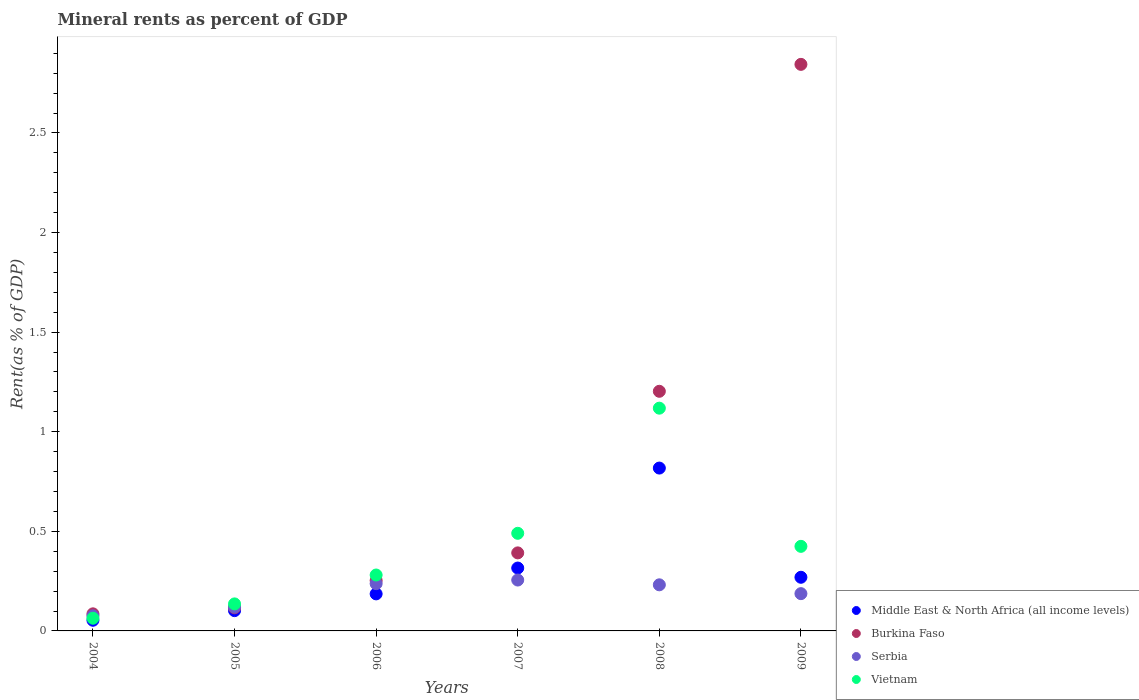Is the number of dotlines equal to the number of legend labels?
Make the answer very short. Yes. What is the mineral rent in Burkina Faso in 2008?
Make the answer very short. 1.2. Across all years, what is the maximum mineral rent in Vietnam?
Your response must be concise. 1.12. Across all years, what is the minimum mineral rent in Burkina Faso?
Your response must be concise. 0.09. In which year was the mineral rent in Middle East & North Africa (all income levels) maximum?
Your response must be concise. 2008. In which year was the mineral rent in Vietnam minimum?
Give a very brief answer. 2004. What is the total mineral rent in Middle East & North Africa (all income levels) in the graph?
Give a very brief answer. 1.74. What is the difference between the mineral rent in Middle East & North Africa (all income levels) in 2007 and that in 2008?
Make the answer very short. -0.5. What is the difference between the mineral rent in Burkina Faso in 2006 and the mineral rent in Vietnam in 2009?
Your answer should be compact. -0.17. What is the average mineral rent in Middle East & North Africa (all income levels) per year?
Your answer should be very brief. 0.29. In the year 2007, what is the difference between the mineral rent in Middle East & North Africa (all income levels) and mineral rent in Vietnam?
Keep it short and to the point. -0.17. In how many years, is the mineral rent in Burkina Faso greater than 0.30000000000000004 %?
Give a very brief answer. 3. What is the ratio of the mineral rent in Middle East & North Africa (all income levels) in 2004 to that in 2006?
Your response must be concise. 0.29. What is the difference between the highest and the second highest mineral rent in Vietnam?
Keep it short and to the point. 0.63. What is the difference between the highest and the lowest mineral rent in Middle East & North Africa (all income levels)?
Provide a short and direct response. 0.76. In how many years, is the mineral rent in Middle East & North Africa (all income levels) greater than the average mineral rent in Middle East & North Africa (all income levels) taken over all years?
Your response must be concise. 2. Is the sum of the mineral rent in Middle East & North Africa (all income levels) in 2004 and 2005 greater than the maximum mineral rent in Vietnam across all years?
Offer a terse response. No. How many dotlines are there?
Your answer should be compact. 4. Are the values on the major ticks of Y-axis written in scientific E-notation?
Your answer should be compact. No. Where does the legend appear in the graph?
Your answer should be compact. Bottom right. How are the legend labels stacked?
Give a very brief answer. Vertical. What is the title of the graph?
Offer a very short reply. Mineral rents as percent of GDP. What is the label or title of the Y-axis?
Keep it short and to the point. Rent(as % of GDP). What is the Rent(as % of GDP) in Middle East & North Africa (all income levels) in 2004?
Offer a very short reply. 0.05. What is the Rent(as % of GDP) in Burkina Faso in 2004?
Provide a succinct answer. 0.09. What is the Rent(as % of GDP) of Serbia in 2004?
Ensure brevity in your answer.  0.08. What is the Rent(as % of GDP) of Vietnam in 2004?
Give a very brief answer. 0.06. What is the Rent(as % of GDP) of Middle East & North Africa (all income levels) in 2005?
Give a very brief answer. 0.1. What is the Rent(as % of GDP) of Burkina Faso in 2005?
Give a very brief answer. 0.12. What is the Rent(as % of GDP) in Serbia in 2005?
Give a very brief answer. 0.12. What is the Rent(as % of GDP) in Vietnam in 2005?
Keep it short and to the point. 0.14. What is the Rent(as % of GDP) of Middle East & North Africa (all income levels) in 2006?
Offer a terse response. 0.19. What is the Rent(as % of GDP) in Burkina Faso in 2006?
Make the answer very short. 0.25. What is the Rent(as % of GDP) in Serbia in 2006?
Offer a terse response. 0.24. What is the Rent(as % of GDP) in Vietnam in 2006?
Offer a terse response. 0.28. What is the Rent(as % of GDP) of Middle East & North Africa (all income levels) in 2007?
Make the answer very short. 0.32. What is the Rent(as % of GDP) in Burkina Faso in 2007?
Make the answer very short. 0.39. What is the Rent(as % of GDP) of Serbia in 2007?
Keep it short and to the point. 0.26. What is the Rent(as % of GDP) of Vietnam in 2007?
Your answer should be very brief. 0.49. What is the Rent(as % of GDP) in Middle East & North Africa (all income levels) in 2008?
Offer a terse response. 0.82. What is the Rent(as % of GDP) in Burkina Faso in 2008?
Give a very brief answer. 1.2. What is the Rent(as % of GDP) in Serbia in 2008?
Offer a very short reply. 0.23. What is the Rent(as % of GDP) of Vietnam in 2008?
Your answer should be very brief. 1.12. What is the Rent(as % of GDP) of Middle East & North Africa (all income levels) in 2009?
Provide a succinct answer. 0.27. What is the Rent(as % of GDP) in Burkina Faso in 2009?
Ensure brevity in your answer.  2.84. What is the Rent(as % of GDP) in Serbia in 2009?
Make the answer very short. 0.19. What is the Rent(as % of GDP) in Vietnam in 2009?
Your answer should be compact. 0.42. Across all years, what is the maximum Rent(as % of GDP) of Middle East & North Africa (all income levels)?
Your answer should be very brief. 0.82. Across all years, what is the maximum Rent(as % of GDP) of Burkina Faso?
Offer a terse response. 2.84. Across all years, what is the maximum Rent(as % of GDP) in Serbia?
Make the answer very short. 0.26. Across all years, what is the maximum Rent(as % of GDP) of Vietnam?
Your answer should be compact. 1.12. Across all years, what is the minimum Rent(as % of GDP) in Middle East & North Africa (all income levels)?
Ensure brevity in your answer.  0.05. Across all years, what is the minimum Rent(as % of GDP) of Burkina Faso?
Keep it short and to the point. 0.09. Across all years, what is the minimum Rent(as % of GDP) of Serbia?
Your answer should be compact. 0.08. Across all years, what is the minimum Rent(as % of GDP) of Vietnam?
Make the answer very short. 0.06. What is the total Rent(as % of GDP) of Middle East & North Africa (all income levels) in the graph?
Ensure brevity in your answer.  1.74. What is the total Rent(as % of GDP) of Burkina Faso in the graph?
Your answer should be compact. 4.89. What is the total Rent(as % of GDP) in Serbia in the graph?
Ensure brevity in your answer.  1.11. What is the total Rent(as % of GDP) of Vietnam in the graph?
Keep it short and to the point. 2.51. What is the difference between the Rent(as % of GDP) of Middle East & North Africa (all income levels) in 2004 and that in 2005?
Keep it short and to the point. -0.05. What is the difference between the Rent(as % of GDP) in Burkina Faso in 2004 and that in 2005?
Ensure brevity in your answer.  -0.03. What is the difference between the Rent(as % of GDP) of Serbia in 2004 and that in 2005?
Provide a succinct answer. -0.04. What is the difference between the Rent(as % of GDP) of Vietnam in 2004 and that in 2005?
Your answer should be very brief. -0.07. What is the difference between the Rent(as % of GDP) in Middle East & North Africa (all income levels) in 2004 and that in 2006?
Your response must be concise. -0.13. What is the difference between the Rent(as % of GDP) in Burkina Faso in 2004 and that in 2006?
Your response must be concise. -0.17. What is the difference between the Rent(as % of GDP) in Serbia in 2004 and that in 2006?
Offer a very short reply. -0.16. What is the difference between the Rent(as % of GDP) of Vietnam in 2004 and that in 2006?
Offer a terse response. -0.22. What is the difference between the Rent(as % of GDP) in Middle East & North Africa (all income levels) in 2004 and that in 2007?
Provide a short and direct response. -0.26. What is the difference between the Rent(as % of GDP) in Burkina Faso in 2004 and that in 2007?
Offer a very short reply. -0.31. What is the difference between the Rent(as % of GDP) of Serbia in 2004 and that in 2007?
Ensure brevity in your answer.  -0.18. What is the difference between the Rent(as % of GDP) of Vietnam in 2004 and that in 2007?
Keep it short and to the point. -0.43. What is the difference between the Rent(as % of GDP) in Middle East & North Africa (all income levels) in 2004 and that in 2008?
Keep it short and to the point. -0.76. What is the difference between the Rent(as % of GDP) in Burkina Faso in 2004 and that in 2008?
Make the answer very short. -1.12. What is the difference between the Rent(as % of GDP) in Serbia in 2004 and that in 2008?
Provide a succinct answer. -0.16. What is the difference between the Rent(as % of GDP) of Vietnam in 2004 and that in 2008?
Your answer should be compact. -1.05. What is the difference between the Rent(as % of GDP) in Middle East & North Africa (all income levels) in 2004 and that in 2009?
Offer a terse response. -0.22. What is the difference between the Rent(as % of GDP) of Burkina Faso in 2004 and that in 2009?
Your answer should be compact. -2.76. What is the difference between the Rent(as % of GDP) in Serbia in 2004 and that in 2009?
Give a very brief answer. -0.11. What is the difference between the Rent(as % of GDP) in Vietnam in 2004 and that in 2009?
Offer a terse response. -0.36. What is the difference between the Rent(as % of GDP) in Middle East & North Africa (all income levels) in 2005 and that in 2006?
Keep it short and to the point. -0.08. What is the difference between the Rent(as % of GDP) in Burkina Faso in 2005 and that in 2006?
Your response must be concise. -0.14. What is the difference between the Rent(as % of GDP) in Serbia in 2005 and that in 2006?
Keep it short and to the point. -0.12. What is the difference between the Rent(as % of GDP) in Vietnam in 2005 and that in 2006?
Your response must be concise. -0.14. What is the difference between the Rent(as % of GDP) of Middle East & North Africa (all income levels) in 2005 and that in 2007?
Make the answer very short. -0.21. What is the difference between the Rent(as % of GDP) of Burkina Faso in 2005 and that in 2007?
Your response must be concise. -0.28. What is the difference between the Rent(as % of GDP) in Serbia in 2005 and that in 2007?
Make the answer very short. -0.14. What is the difference between the Rent(as % of GDP) in Vietnam in 2005 and that in 2007?
Your response must be concise. -0.35. What is the difference between the Rent(as % of GDP) in Middle East & North Africa (all income levels) in 2005 and that in 2008?
Give a very brief answer. -0.72. What is the difference between the Rent(as % of GDP) of Burkina Faso in 2005 and that in 2008?
Your response must be concise. -1.09. What is the difference between the Rent(as % of GDP) of Serbia in 2005 and that in 2008?
Keep it short and to the point. -0.11. What is the difference between the Rent(as % of GDP) of Vietnam in 2005 and that in 2008?
Your answer should be compact. -0.98. What is the difference between the Rent(as % of GDP) of Middle East & North Africa (all income levels) in 2005 and that in 2009?
Offer a very short reply. -0.17. What is the difference between the Rent(as % of GDP) of Burkina Faso in 2005 and that in 2009?
Give a very brief answer. -2.73. What is the difference between the Rent(as % of GDP) of Serbia in 2005 and that in 2009?
Give a very brief answer. -0.07. What is the difference between the Rent(as % of GDP) of Vietnam in 2005 and that in 2009?
Your answer should be very brief. -0.29. What is the difference between the Rent(as % of GDP) in Middle East & North Africa (all income levels) in 2006 and that in 2007?
Your answer should be compact. -0.13. What is the difference between the Rent(as % of GDP) in Burkina Faso in 2006 and that in 2007?
Make the answer very short. -0.14. What is the difference between the Rent(as % of GDP) of Serbia in 2006 and that in 2007?
Give a very brief answer. -0.02. What is the difference between the Rent(as % of GDP) of Vietnam in 2006 and that in 2007?
Your answer should be compact. -0.21. What is the difference between the Rent(as % of GDP) of Middle East & North Africa (all income levels) in 2006 and that in 2008?
Give a very brief answer. -0.63. What is the difference between the Rent(as % of GDP) in Burkina Faso in 2006 and that in 2008?
Your answer should be very brief. -0.95. What is the difference between the Rent(as % of GDP) in Serbia in 2006 and that in 2008?
Give a very brief answer. 0.01. What is the difference between the Rent(as % of GDP) of Vietnam in 2006 and that in 2008?
Give a very brief answer. -0.84. What is the difference between the Rent(as % of GDP) in Middle East & North Africa (all income levels) in 2006 and that in 2009?
Give a very brief answer. -0.08. What is the difference between the Rent(as % of GDP) of Burkina Faso in 2006 and that in 2009?
Give a very brief answer. -2.59. What is the difference between the Rent(as % of GDP) of Serbia in 2006 and that in 2009?
Offer a very short reply. 0.05. What is the difference between the Rent(as % of GDP) of Vietnam in 2006 and that in 2009?
Your answer should be very brief. -0.14. What is the difference between the Rent(as % of GDP) in Middle East & North Africa (all income levels) in 2007 and that in 2008?
Offer a very short reply. -0.5. What is the difference between the Rent(as % of GDP) in Burkina Faso in 2007 and that in 2008?
Offer a terse response. -0.81. What is the difference between the Rent(as % of GDP) in Serbia in 2007 and that in 2008?
Make the answer very short. 0.02. What is the difference between the Rent(as % of GDP) in Vietnam in 2007 and that in 2008?
Your response must be concise. -0.63. What is the difference between the Rent(as % of GDP) of Middle East & North Africa (all income levels) in 2007 and that in 2009?
Offer a very short reply. 0.05. What is the difference between the Rent(as % of GDP) of Burkina Faso in 2007 and that in 2009?
Give a very brief answer. -2.45. What is the difference between the Rent(as % of GDP) in Serbia in 2007 and that in 2009?
Give a very brief answer. 0.07. What is the difference between the Rent(as % of GDP) of Vietnam in 2007 and that in 2009?
Your answer should be compact. 0.07. What is the difference between the Rent(as % of GDP) of Middle East & North Africa (all income levels) in 2008 and that in 2009?
Give a very brief answer. 0.55. What is the difference between the Rent(as % of GDP) in Burkina Faso in 2008 and that in 2009?
Your answer should be very brief. -1.64. What is the difference between the Rent(as % of GDP) of Serbia in 2008 and that in 2009?
Provide a short and direct response. 0.04. What is the difference between the Rent(as % of GDP) of Vietnam in 2008 and that in 2009?
Provide a succinct answer. 0.69. What is the difference between the Rent(as % of GDP) of Middle East & North Africa (all income levels) in 2004 and the Rent(as % of GDP) of Burkina Faso in 2005?
Make the answer very short. -0.06. What is the difference between the Rent(as % of GDP) of Middle East & North Africa (all income levels) in 2004 and the Rent(as % of GDP) of Serbia in 2005?
Offer a terse response. -0.07. What is the difference between the Rent(as % of GDP) of Middle East & North Africa (all income levels) in 2004 and the Rent(as % of GDP) of Vietnam in 2005?
Provide a short and direct response. -0.08. What is the difference between the Rent(as % of GDP) in Burkina Faso in 2004 and the Rent(as % of GDP) in Serbia in 2005?
Give a very brief answer. -0.03. What is the difference between the Rent(as % of GDP) in Burkina Faso in 2004 and the Rent(as % of GDP) in Vietnam in 2005?
Your answer should be very brief. -0.05. What is the difference between the Rent(as % of GDP) in Serbia in 2004 and the Rent(as % of GDP) in Vietnam in 2005?
Ensure brevity in your answer.  -0.06. What is the difference between the Rent(as % of GDP) of Middle East & North Africa (all income levels) in 2004 and the Rent(as % of GDP) of Burkina Faso in 2006?
Provide a succinct answer. -0.2. What is the difference between the Rent(as % of GDP) in Middle East & North Africa (all income levels) in 2004 and the Rent(as % of GDP) in Serbia in 2006?
Provide a short and direct response. -0.18. What is the difference between the Rent(as % of GDP) of Middle East & North Africa (all income levels) in 2004 and the Rent(as % of GDP) of Vietnam in 2006?
Keep it short and to the point. -0.23. What is the difference between the Rent(as % of GDP) in Burkina Faso in 2004 and the Rent(as % of GDP) in Serbia in 2006?
Your response must be concise. -0.15. What is the difference between the Rent(as % of GDP) in Burkina Faso in 2004 and the Rent(as % of GDP) in Vietnam in 2006?
Your answer should be very brief. -0.19. What is the difference between the Rent(as % of GDP) in Serbia in 2004 and the Rent(as % of GDP) in Vietnam in 2006?
Your response must be concise. -0.2. What is the difference between the Rent(as % of GDP) of Middle East & North Africa (all income levels) in 2004 and the Rent(as % of GDP) of Burkina Faso in 2007?
Give a very brief answer. -0.34. What is the difference between the Rent(as % of GDP) in Middle East & North Africa (all income levels) in 2004 and the Rent(as % of GDP) in Serbia in 2007?
Ensure brevity in your answer.  -0.2. What is the difference between the Rent(as % of GDP) of Middle East & North Africa (all income levels) in 2004 and the Rent(as % of GDP) of Vietnam in 2007?
Keep it short and to the point. -0.44. What is the difference between the Rent(as % of GDP) in Burkina Faso in 2004 and the Rent(as % of GDP) in Serbia in 2007?
Your response must be concise. -0.17. What is the difference between the Rent(as % of GDP) of Burkina Faso in 2004 and the Rent(as % of GDP) of Vietnam in 2007?
Your answer should be compact. -0.4. What is the difference between the Rent(as % of GDP) of Serbia in 2004 and the Rent(as % of GDP) of Vietnam in 2007?
Give a very brief answer. -0.41. What is the difference between the Rent(as % of GDP) of Middle East & North Africa (all income levels) in 2004 and the Rent(as % of GDP) of Burkina Faso in 2008?
Make the answer very short. -1.15. What is the difference between the Rent(as % of GDP) of Middle East & North Africa (all income levels) in 2004 and the Rent(as % of GDP) of Serbia in 2008?
Your answer should be very brief. -0.18. What is the difference between the Rent(as % of GDP) of Middle East & North Africa (all income levels) in 2004 and the Rent(as % of GDP) of Vietnam in 2008?
Your answer should be compact. -1.06. What is the difference between the Rent(as % of GDP) in Burkina Faso in 2004 and the Rent(as % of GDP) in Serbia in 2008?
Offer a very short reply. -0.15. What is the difference between the Rent(as % of GDP) in Burkina Faso in 2004 and the Rent(as % of GDP) in Vietnam in 2008?
Your answer should be compact. -1.03. What is the difference between the Rent(as % of GDP) of Serbia in 2004 and the Rent(as % of GDP) of Vietnam in 2008?
Ensure brevity in your answer.  -1.04. What is the difference between the Rent(as % of GDP) of Middle East & North Africa (all income levels) in 2004 and the Rent(as % of GDP) of Burkina Faso in 2009?
Keep it short and to the point. -2.79. What is the difference between the Rent(as % of GDP) of Middle East & North Africa (all income levels) in 2004 and the Rent(as % of GDP) of Serbia in 2009?
Provide a succinct answer. -0.13. What is the difference between the Rent(as % of GDP) in Middle East & North Africa (all income levels) in 2004 and the Rent(as % of GDP) in Vietnam in 2009?
Offer a very short reply. -0.37. What is the difference between the Rent(as % of GDP) in Burkina Faso in 2004 and the Rent(as % of GDP) in Serbia in 2009?
Provide a succinct answer. -0.1. What is the difference between the Rent(as % of GDP) in Burkina Faso in 2004 and the Rent(as % of GDP) in Vietnam in 2009?
Provide a short and direct response. -0.34. What is the difference between the Rent(as % of GDP) in Serbia in 2004 and the Rent(as % of GDP) in Vietnam in 2009?
Offer a terse response. -0.35. What is the difference between the Rent(as % of GDP) in Middle East & North Africa (all income levels) in 2005 and the Rent(as % of GDP) in Burkina Faso in 2006?
Give a very brief answer. -0.15. What is the difference between the Rent(as % of GDP) of Middle East & North Africa (all income levels) in 2005 and the Rent(as % of GDP) of Serbia in 2006?
Give a very brief answer. -0.14. What is the difference between the Rent(as % of GDP) of Middle East & North Africa (all income levels) in 2005 and the Rent(as % of GDP) of Vietnam in 2006?
Your answer should be very brief. -0.18. What is the difference between the Rent(as % of GDP) in Burkina Faso in 2005 and the Rent(as % of GDP) in Serbia in 2006?
Your answer should be very brief. -0.12. What is the difference between the Rent(as % of GDP) in Burkina Faso in 2005 and the Rent(as % of GDP) in Vietnam in 2006?
Offer a very short reply. -0.16. What is the difference between the Rent(as % of GDP) in Serbia in 2005 and the Rent(as % of GDP) in Vietnam in 2006?
Keep it short and to the point. -0.16. What is the difference between the Rent(as % of GDP) in Middle East & North Africa (all income levels) in 2005 and the Rent(as % of GDP) in Burkina Faso in 2007?
Ensure brevity in your answer.  -0.29. What is the difference between the Rent(as % of GDP) in Middle East & North Africa (all income levels) in 2005 and the Rent(as % of GDP) in Serbia in 2007?
Your answer should be compact. -0.15. What is the difference between the Rent(as % of GDP) of Middle East & North Africa (all income levels) in 2005 and the Rent(as % of GDP) of Vietnam in 2007?
Offer a very short reply. -0.39. What is the difference between the Rent(as % of GDP) in Burkina Faso in 2005 and the Rent(as % of GDP) in Serbia in 2007?
Make the answer very short. -0.14. What is the difference between the Rent(as % of GDP) in Burkina Faso in 2005 and the Rent(as % of GDP) in Vietnam in 2007?
Make the answer very short. -0.37. What is the difference between the Rent(as % of GDP) of Serbia in 2005 and the Rent(as % of GDP) of Vietnam in 2007?
Ensure brevity in your answer.  -0.37. What is the difference between the Rent(as % of GDP) of Middle East & North Africa (all income levels) in 2005 and the Rent(as % of GDP) of Burkina Faso in 2008?
Your response must be concise. -1.1. What is the difference between the Rent(as % of GDP) in Middle East & North Africa (all income levels) in 2005 and the Rent(as % of GDP) in Serbia in 2008?
Offer a terse response. -0.13. What is the difference between the Rent(as % of GDP) in Middle East & North Africa (all income levels) in 2005 and the Rent(as % of GDP) in Vietnam in 2008?
Provide a succinct answer. -1.02. What is the difference between the Rent(as % of GDP) in Burkina Faso in 2005 and the Rent(as % of GDP) in Serbia in 2008?
Your response must be concise. -0.12. What is the difference between the Rent(as % of GDP) of Burkina Faso in 2005 and the Rent(as % of GDP) of Vietnam in 2008?
Provide a succinct answer. -1. What is the difference between the Rent(as % of GDP) in Serbia in 2005 and the Rent(as % of GDP) in Vietnam in 2008?
Offer a very short reply. -1. What is the difference between the Rent(as % of GDP) in Middle East & North Africa (all income levels) in 2005 and the Rent(as % of GDP) in Burkina Faso in 2009?
Make the answer very short. -2.74. What is the difference between the Rent(as % of GDP) in Middle East & North Africa (all income levels) in 2005 and the Rent(as % of GDP) in Serbia in 2009?
Offer a very short reply. -0.09. What is the difference between the Rent(as % of GDP) of Middle East & North Africa (all income levels) in 2005 and the Rent(as % of GDP) of Vietnam in 2009?
Offer a very short reply. -0.32. What is the difference between the Rent(as % of GDP) of Burkina Faso in 2005 and the Rent(as % of GDP) of Serbia in 2009?
Provide a short and direct response. -0.07. What is the difference between the Rent(as % of GDP) of Burkina Faso in 2005 and the Rent(as % of GDP) of Vietnam in 2009?
Offer a very short reply. -0.31. What is the difference between the Rent(as % of GDP) in Serbia in 2005 and the Rent(as % of GDP) in Vietnam in 2009?
Offer a terse response. -0.31. What is the difference between the Rent(as % of GDP) of Middle East & North Africa (all income levels) in 2006 and the Rent(as % of GDP) of Burkina Faso in 2007?
Offer a terse response. -0.21. What is the difference between the Rent(as % of GDP) in Middle East & North Africa (all income levels) in 2006 and the Rent(as % of GDP) in Serbia in 2007?
Your answer should be very brief. -0.07. What is the difference between the Rent(as % of GDP) of Middle East & North Africa (all income levels) in 2006 and the Rent(as % of GDP) of Vietnam in 2007?
Your answer should be compact. -0.3. What is the difference between the Rent(as % of GDP) of Burkina Faso in 2006 and the Rent(as % of GDP) of Serbia in 2007?
Offer a terse response. -0. What is the difference between the Rent(as % of GDP) in Burkina Faso in 2006 and the Rent(as % of GDP) in Vietnam in 2007?
Ensure brevity in your answer.  -0.24. What is the difference between the Rent(as % of GDP) of Serbia in 2006 and the Rent(as % of GDP) of Vietnam in 2007?
Your answer should be compact. -0.25. What is the difference between the Rent(as % of GDP) of Middle East & North Africa (all income levels) in 2006 and the Rent(as % of GDP) of Burkina Faso in 2008?
Offer a terse response. -1.02. What is the difference between the Rent(as % of GDP) in Middle East & North Africa (all income levels) in 2006 and the Rent(as % of GDP) in Serbia in 2008?
Offer a very short reply. -0.05. What is the difference between the Rent(as % of GDP) in Middle East & North Africa (all income levels) in 2006 and the Rent(as % of GDP) in Vietnam in 2008?
Offer a very short reply. -0.93. What is the difference between the Rent(as % of GDP) of Burkina Faso in 2006 and the Rent(as % of GDP) of Serbia in 2008?
Your answer should be very brief. 0.02. What is the difference between the Rent(as % of GDP) in Burkina Faso in 2006 and the Rent(as % of GDP) in Vietnam in 2008?
Your answer should be very brief. -0.87. What is the difference between the Rent(as % of GDP) in Serbia in 2006 and the Rent(as % of GDP) in Vietnam in 2008?
Offer a very short reply. -0.88. What is the difference between the Rent(as % of GDP) in Middle East & North Africa (all income levels) in 2006 and the Rent(as % of GDP) in Burkina Faso in 2009?
Make the answer very short. -2.66. What is the difference between the Rent(as % of GDP) of Middle East & North Africa (all income levels) in 2006 and the Rent(as % of GDP) of Serbia in 2009?
Give a very brief answer. -0. What is the difference between the Rent(as % of GDP) in Middle East & North Africa (all income levels) in 2006 and the Rent(as % of GDP) in Vietnam in 2009?
Your answer should be very brief. -0.24. What is the difference between the Rent(as % of GDP) in Burkina Faso in 2006 and the Rent(as % of GDP) in Serbia in 2009?
Keep it short and to the point. 0.07. What is the difference between the Rent(as % of GDP) in Burkina Faso in 2006 and the Rent(as % of GDP) in Vietnam in 2009?
Your answer should be compact. -0.17. What is the difference between the Rent(as % of GDP) of Serbia in 2006 and the Rent(as % of GDP) of Vietnam in 2009?
Provide a succinct answer. -0.19. What is the difference between the Rent(as % of GDP) of Middle East & North Africa (all income levels) in 2007 and the Rent(as % of GDP) of Burkina Faso in 2008?
Make the answer very short. -0.89. What is the difference between the Rent(as % of GDP) in Middle East & North Africa (all income levels) in 2007 and the Rent(as % of GDP) in Serbia in 2008?
Ensure brevity in your answer.  0.08. What is the difference between the Rent(as % of GDP) in Middle East & North Africa (all income levels) in 2007 and the Rent(as % of GDP) in Vietnam in 2008?
Ensure brevity in your answer.  -0.8. What is the difference between the Rent(as % of GDP) in Burkina Faso in 2007 and the Rent(as % of GDP) in Serbia in 2008?
Ensure brevity in your answer.  0.16. What is the difference between the Rent(as % of GDP) of Burkina Faso in 2007 and the Rent(as % of GDP) of Vietnam in 2008?
Offer a very short reply. -0.73. What is the difference between the Rent(as % of GDP) of Serbia in 2007 and the Rent(as % of GDP) of Vietnam in 2008?
Your answer should be compact. -0.86. What is the difference between the Rent(as % of GDP) of Middle East & North Africa (all income levels) in 2007 and the Rent(as % of GDP) of Burkina Faso in 2009?
Your response must be concise. -2.53. What is the difference between the Rent(as % of GDP) of Middle East & North Africa (all income levels) in 2007 and the Rent(as % of GDP) of Serbia in 2009?
Offer a terse response. 0.13. What is the difference between the Rent(as % of GDP) of Middle East & North Africa (all income levels) in 2007 and the Rent(as % of GDP) of Vietnam in 2009?
Give a very brief answer. -0.11. What is the difference between the Rent(as % of GDP) in Burkina Faso in 2007 and the Rent(as % of GDP) in Serbia in 2009?
Your response must be concise. 0.2. What is the difference between the Rent(as % of GDP) of Burkina Faso in 2007 and the Rent(as % of GDP) of Vietnam in 2009?
Your answer should be very brief. -0.03. What is the difference between the Rent(as % of GDP) of Serbia in 2007 and the Rent(as % of GDP) of Vietnam in 2009?
Your response must be concise. -0.17. What is the difference between the Rent(as % of GDP) of Middle East & North Africa (all income levels) in 2008 and the Rent(as % of GDP) of Burkina Faso in 2009?
Make the answer very short. -2.03. What is the difference between the Rent(as % of GDP) of Middle East & North Africa (all income levels) in 2008 and the Rent(as % of GDP) of Serbia in 2009?
Offer a terse response. 0.63. What is the difference between the Rent(as % of GDP) in Middle East & North Africa (all income levels) in 2008 and the Rent(as % of GDP) in Vietnam in 2009?
Your answer should be very brief. 0.39. What is the difference between the Rent(as % of GDP) in Burkina Faso in 2008 and the Rent(as % of GDP) in Serbia in 2009?
Provide a succinct answer. 1.02. What is the difference between the Rent(as % of GDP) of Burkina Faso in 2008 and the Rent(as % of GDP) of Vietnam in 2009?
Keep it short and to the point. 0.78. What is the difference between the Rent(as % of GDP) of Serbia in 2008 and the Rent(as % of GDP) of Vietnam in 2009?
Offer a very short reply. -0.19. What is the average Rent(as % of GDP) of Middle East & North Africa (all income levels) per year?
Your answer should be very brief. 0.29. What is the average Rent(as % of GDP) in Burkina Faso per year?
Offer a terse response. 0.82. What is the average Rent(as % of GDP) of Serbia per year?
Your response must be concise. 0.18. What is the average Rent(as % of GDP) of Vietnam per year?
Ensure brevity in your answer.  0.42. In the year 2004, what is the difference between the Rent(as % of GDP) in Middle East & North Africa (all income levels) and Rent(as % of GDP) in Burkina Faso?
Keep it short and to the point. -0.03. In the year 2004, what is the difference between the Rent(as % of GDP) of Middle East & North Africa (all income levels) and Rent(as % of GDP) of Serbia?
Keep it short and to the point. -0.02. In the year 2004, what is the difference between the Rent(as % of GDP) in Middle East & North Africa (all income levels) and Rent(as % of GDP) in Vietnam?
Provide a succinct answer. -0.01. In the year 2004, what is the difference between the Rent(as % of GDP) in Burkina Faso and Rent(as % of GDP) in Serbia?
Provide a succinct answer. 0.01. In the year 2004, what is the difference between the Rent(as % of GDP) in Burkina Faso and Rent(as % of GDP) in Vietnam?
Provide a short and direct response. 0.02. In the year 2004, what is the difference between the Rent(as % of GDP) in Serbia and Rent(as % of GDP) in Vietnam?
Offer a very short reply. 0.01. In the year 2005, what is the difference between the Rent(as % of GDP) of Middle East & North Africa (all income levels) and Rent(as % of GDP) of Burkina Faso?
Make the answer very short. -0.01. In the year 2005, what is the difference between the Rent(as % of GDP) of Middle East & North Africa (all income levels) and Rent(as % of GDP) of Serbia?
Your response must be concise. -0.02. In the year 2005, what is the difference between the Rent(as % of GDP) of Middle East & North Africa (all income levels) and Rent(as % of GDP) of Vietnam?
Ensure brevity in your answer.  -0.03. In the year 2005, what is the difference between the Rent(as % of GDP) in Burkina Faso and Rent(as % of GDP) in Serbia?
Keep it short and to the point. -0. In the year 2005, what is the difference between the Rent(as % of GDP) of Burkina Faso and Rent(as % of GDP) of Vietnam?
Offer a very short reply. -0.02. In the year 2005, what is the difference between the Rent(as % of GDP) of Serbia and Rent(as % of GDP) of Vietnam?
Make the answer very short. -0.02. In the year 2006, what is the difference between the Rent(as % of GDP) of Middle East & North Africa (all income levels) and Rent(as % of GDP) of Burkina Faso?
Make the answer very short. -0.07. In the year 2006, what is the difference between the Rent(as % of GDP) in Middle East & North Africa (all income levels) and Rent(as % of GDP) in Serbia?
Offer a very short reply. -0.05. In the year 2006, what is the difference between the Rent(as % of GDP) of Middle East & North Africa (all income levels) and Rent(as % of GDP) of Vietnam?
Your answer should be very brief. -0.09. In the year 2006, what is the difference between the Rent(as % of GDP) in Burkina Faso and Rent(as % of GDP) in Serbia?
Keep it short and to the point. 0.02. In the year 2006, what is the difference between the Rent(as % of GDP) in Burkina Faso and Rent(as % of GDP) in Vietnam?
Offer a terse response. -0.03. In the year 2006, what is the difference between the Rent(as % of GDP) of Serbia and Rent(as % of GDP) of Vietnam?
Make the answer very short. -0.04. In the year 2007, what is the difference between the Rent(as % of GDP) of Middle East & North Africa (all income levels) and Rent(as % of GDP) of Burkina Faso?
Offer a very short reply. -0.08. In the year 2007, what is the difference between the Rent(as % of GDP) of Middle East & North Africa (all income levels) and Rent(as % of GDP) of Serbia?
Make the answer very short. 0.06. In the year 2007, what is the difference between the Rent(as % of GDP) of Middle East & North Africa (all income levels) and Rent(as % of GDP) of Vietnam?
Your answer should be very brief. -0.17. In the year 2007, what is the difference between the Rent(as % of GDP) of Burkina Faso and Rent(as % of GDP) of Serbia?
Your answer should be compact. 0.14. In the year 2007, what is the difference between the Rent(as % of GDP) of Burkina Faso and Rent(as % of GDP) of Vietnam?
Make the answer very short. -0.1. In the year 2007, what is the difference between the Rent(as % of GDP) of Serbia and Rent(as % of GDP) of Vietnam?
Provide a short and direct response. -0.23. In the year 2008, what is the difference between the Rent(as % of GDP) of Middle East & North Africa (all income levels) and Rent(as % of GDP) of Burkina Faso?
Make the answer very short. -0.39. In the year 2008, what is the difference between the Rent(as % of GDP) in Middle East & North Africa (all income levels) and Rent(as % of GDP) in Serbia?
Give a very brief answer. 0.59. In the year 2008, what is the difference between the Rent(as % of GDP) of Middle East & North Africa (all income levels) and Rent(as % of GDP) of Vietnam?
Offer a terse response. -0.3. In the year 2008, what is the difference between the Rent(as % of GDP) of Burkina Faso and Rent(as % of GDP) of Serbia?
Make the answer very short. 0.97. In the year 2008, what is the difference between the Rent(as % of GDP) in Burkina Faso and Rent(as % of GDP) in Vietnam?
Offer a terse response. 0.08. In the year 2008, what is the difference between the Rent(as % of GDP) in Serbia and Rent(as % of GDP) in Vietnam?
Keep it short and to the point. -0.89. In the year 2009, what is the difference between the Rent(as % of GDP) of Middle East & North Africa (all income levels) and Rent(as % of GDP) of Burkina Faso?
Provide a short and direct response. -2.57. In the year 2009, what is the difference between the Rent(as % of GDP) of Middle East & North Africa (all income levels) and Rent(as % of GDP) of Serbia?
Provide a succinct answer. 0.08. In the year 2009, what is the difference between the Rent(as % of GDP) in Middle East & North Africa (all income levels) and Rent(as % of GDP) in Vietnam?
Offer a terse response. -0.16. In the year 2009, what is the difference between the Rent(as % of GDP) of Burkina Faso and Rent(as % of GDP) of Serbia?
Your response must be concise. 2.66. In the year 2009, what is the difference between the Rent(as % of GDP) in Burkina Faso and Rent(as % of GDP) in Vietnam?
Make the answer very short. 2.42. In the year 2009, what is the difference between the Rent(as % of GDP) in Serbia and Rent(as % of GDP) in Vietnam?
Your answer should be compact. -0.24. What is the ratio of the Rent(as % of GDP) in Middle East & North Africa (all income levels) in 2004 to that in 2005?
Your answer should be very brief. 0.53. What is the ratio of the Rent(as % of GDP) of Burkina Faso in 2004 to that in 2005?
Your answer should be compact. 0.74. What is the ratio of the Rent(as % of GDP) in Serbia in 2004 to that in 2005?
Your response must be concise. 0.64. What is the ratio of the Rent(as % of GDP) of Vietnam in 2004 to that in 2005?
Offer a terse response. 0.47. What is the ratio of the Rent(as % of GDP) in Middle East & North Africa (all income levels) in 2004 to that in 2006?
Provide a succinct answer. 0.29. What is the ratio of the Rent(as % of GDP) in Burkina Faso in 2004 to that in 2006?
Your answer should be very brief. 0.34. What is the ratio of the Rent(as % of GDP) in Serbia in 2004 to that in 2006?
Provide a succinct answer. 0.32. What is the ratio of the Rent(as % of GDP) in Vietnam in 2004 to that in 2006?
Offer a terse response. 0.23. What is the ratio of the Rent(as % of GDP) of Middle East & North Africa (all income levels) in 2004 to that in 2007?
Provide a succinct answer. 0.17. What is the ratio of the Rent(as % of GDP) in Burkina Faso in 2004 to that in 2007?
Provide a succinct answer. 0.22. What is the ratio of the Rent(as % of GDP) of Serbia in 2004 to that in 2007?
Keep it short and to the point. 0.3. What is the ratio of the Rent(as % of GDP) in Vietnam in 2004 to that in 2007?
Ensure brevity in your answer.  0.13. What is the ratio of the Rent(as % of GDP) in Middle East & North Africa (all income levels) in 2004 to that in 2008?
Offer a terse response. 0.07. What is the ratio of the Rent(as % of GDP) in Burkina Faso in 2004 to that in 2008?
Make the answer very short. 0.07. What is the ratio of the Rent(as % of GDP) of Serbia in 2004 to that in 2008?
Your answer should be very brief. 0.33. What is the ratio of the Rent(as % of GDP) in Vietnam in 2004 to that in 2008?
Your response must be concise. 0.06. What is the ratio of the Rent(as % of GDP) in Middle East & North Africa (all income levels) in 2004 to that in 2009?
Provide a succinct answer. 0.2. What is the ratio of the Rent(as % of GDP) in Burkina Faso in 2004 to that in 2009?
Offer a terse response. 0.03. What is the ratio of the Rent(as % of GDP) in Serbia in 2004 to that in 2009?
Keep it short and to the point. 0.4. What is the ratio of the Rent(as % of GDP) of Vietnam in 2004 to that in 2009?
Ensure brevity in your answer.  0.15. What is the ratio of the Rent(as % of GDP) in Middle East & North Africa (all income levels) in 2005 to that in 2006?
Provide a succinct answer. 0.55. What is the ratio of the Rent(as % of GDP) of Burkina Faso in 2005 to that in 2006?
Ensure brevity in your answer.  0.46. What is the ratio of the Rent(as % of GDP) in Serbia in 2005 to that in 2006?
Your answer should be compact. 0.5. What is the ratio of the Rent(as % of GDP) of Vietnam in 2005 to that in 2006?
Offer a very short reply. 0.48. What is the ratio of the Rent(as % of GDP) in Middle East & North Africa (all income levels) in 2005 to that in 2007?
Provide a succinct answer. 0.32. What is the ratio of the Rent(as % of GDP) in Burkina Faso in 2005 to that in 2007?
Give a very brief answer. 0.3. What is the ratio of the Rent(as % of GDP) in Serbia in 2005 to that in 2007?
Give a very brief answer. 0.47. What is the ratio of the Rent(as % of GDP) in Vietnam in 2005 to that in 2007?
Offer a terse response. 0.28. What is the ratio of the Rent(as % of GDP) of Middle East & North Africa (all income levels) in 2005 to that in 2008?
Provide a short and direct response. 0.12. What is the ratio of the Rent(as % of GDP) in Burkina Faso in 2005 to that in 2008?
Provide a short and direct response. 0.1. What is the ratio of the Rent(as % of GDP) in Serbia in 2005 to that in 2008?
Ensure brevity in your answer.  0.51. What is the ratio of the Rent(as % of GDP) in Vietnam in 2005 to that in 2008?
Make the answer very short. 0.12. What is the ratio of the Rent(as % of GDP) in Middle East & North Africa (all income levels) in 2005 to that in 2009?
Make the answer very short. 0.38. What is the ratio of the Rent(as % of GDP) of Burkina Faso in 2005 to that in 2009?
Give a very brief answer. 0.04. What is the ratio of the Rent(as % of GDP) in Serbia in 2005 to that in 2009?
Offer a very short reply. 0.64. What is the ratio of the Rent(as % of GDP) in Vietnam in 2005 to that in 2009?
Provide a succinct answer. 0.32. What is the ratio of the Rent(as % of GDP) in Middle East & North Africa (all income levels) in 2006 to that in 2007?
Provide a short and direct response. 0.59. What is the ratio of the Rent(as % of GDP) of Burkina Faso in 2006 to that in 2007?
Offer a very short reply. 0.65. What is the ratio of the Rent(as % of GDP) of Serbia in 2006 to that in 2007?
Ensure brevity in your answer.  0.93. What is the ratio of the Rent(as % of GDP) of Vietnam in 2006 to that in 2007?
Your answer should be compact. 0.57. What is the ratio of the Rent(as % of GDP) in Middle East & North Africa (all income levels) in 2006 to that in 2008?
Make the answer very short. 0.23. What is the ratio of the Rent(as % of GDP) in Burkina Faso in 2006 to that in 2008?
Your response must be concise. 0.21. What is the ratio of the Rent(as % of GDP) in Serbia in 2006 to that in 2008?
Ensure brevity in your answer.  1.02. What is the ratio of the Rent(as % of GDP) of Vietnam in 2006 to that in 2008?
Your answer should be compact. 0.25. What is the ratio of the Rent(as % of GDP) in Middle East & North Africa (all income levels) in 2006 to that in 2009?
Offer a terse response. 0.69. What is the ratio of the Rent(as % of GDP) of Burkina Faso in 2006 to that in 2009?
Make the answer very short. 0.09. What is the ratio of the Rent(as % of GDP) in Serbia in 2006 to that in 2009?
Give a very brief answer. 1.27. What is the ratio of the Rent(as % of GDP) of Vietnam in 2006 to that in 2009?
Provide a short and direct response. 0.66. What is the ratio of the Rent(as % of GDP) in Middle East & North Africa (all income levels) in 2007 to that in 2008?
Your answer should be very brief. 0.39. What is the ratio of the Rent(as % of GDP) of Burkina Faso in 2007 to that in 2008?
Your answer should be compact. 0.33. What is the ratio of the Rent(as % of GDP) in Serbia in 2007 to that in 2008?
Your answer should be very brief. 1.1. What is the ratio of the Rent(as % of GDP) in Vietnam in 2007 to that in 2008?
Your response must be concise. 0.44. What is the ratio of the Rent(as % of GDP) in Middle East & North Africa (all income levels) in 2007 to that in 2009?
Make the answer very short. 1.17. What is the ratio of the Rent(as % of GDP) of Burkina Faso in 2007 to that in 2009?
Offer a very short reply. 0.14. What is the ratio of the Rent(as % of GDP) in Serbia in 2007 to that in 2009?
Ensure brevity in your answer.  1.37. What is the ratio of the Rent(as % of GDP) in Vietnam in 2007 to that in 2009?
Your response must be concise. 1.15. What is the ratio of the Rent(as % of GDP) in Middle East & North Africa (all income levels) in 2008 to that in 2009?
Keep it short and to the point. 3.04. What is the ratio of the Rent(as % of GDP) of Burkina Faso in 2008 to that in 2009?
Provide a succinct answer. 0.42. What is the ratio of the Rent(as % of GDP) of Serbia in 2008 to that in 2009?
Make the answer very short. 1.24. What is the ratio of the Rent(as % of GDP) in Vietnam in 2008 to that in 2009?
Provide a succinct answer. 2.63. What is the difference between the highest and the second highest Rent(as % of GDP) in Middle East & North Africa (all income levels)?
Provide a short and direct response. 0.5. What is the difference between the highest and the second highest Rent(as % of GDP) in Burkina Faso?
Your answer should be very brief. 1.64. What is the difference between the highest and the second highest Rent(as % of GDP) in Serbia?
Provide a short and direct response. 0.02. What is the difference between the highest and the second highest Rent(as % of GDP) of Vietnam?
Your response must be concise. 0.63. What is the difference between the highest and the lowest Rent(as % of GDP) in Middle East & North Africa (all income levels)?
Ensure brevity in your answer.  0.76. What is the difference between the highest and the lowest Rent(as % of GDP) in Burkina Faso?
Make the answer very short. 2.76. What is the difference between the highest and the lowest Rent(as % of GDP) in Serbia?
Provide a short and direct response. 0.18. What is the difference between the highest and the lowest Rent(as % of GDP) of Vietnam?
Make the answer very short. 1.05. 